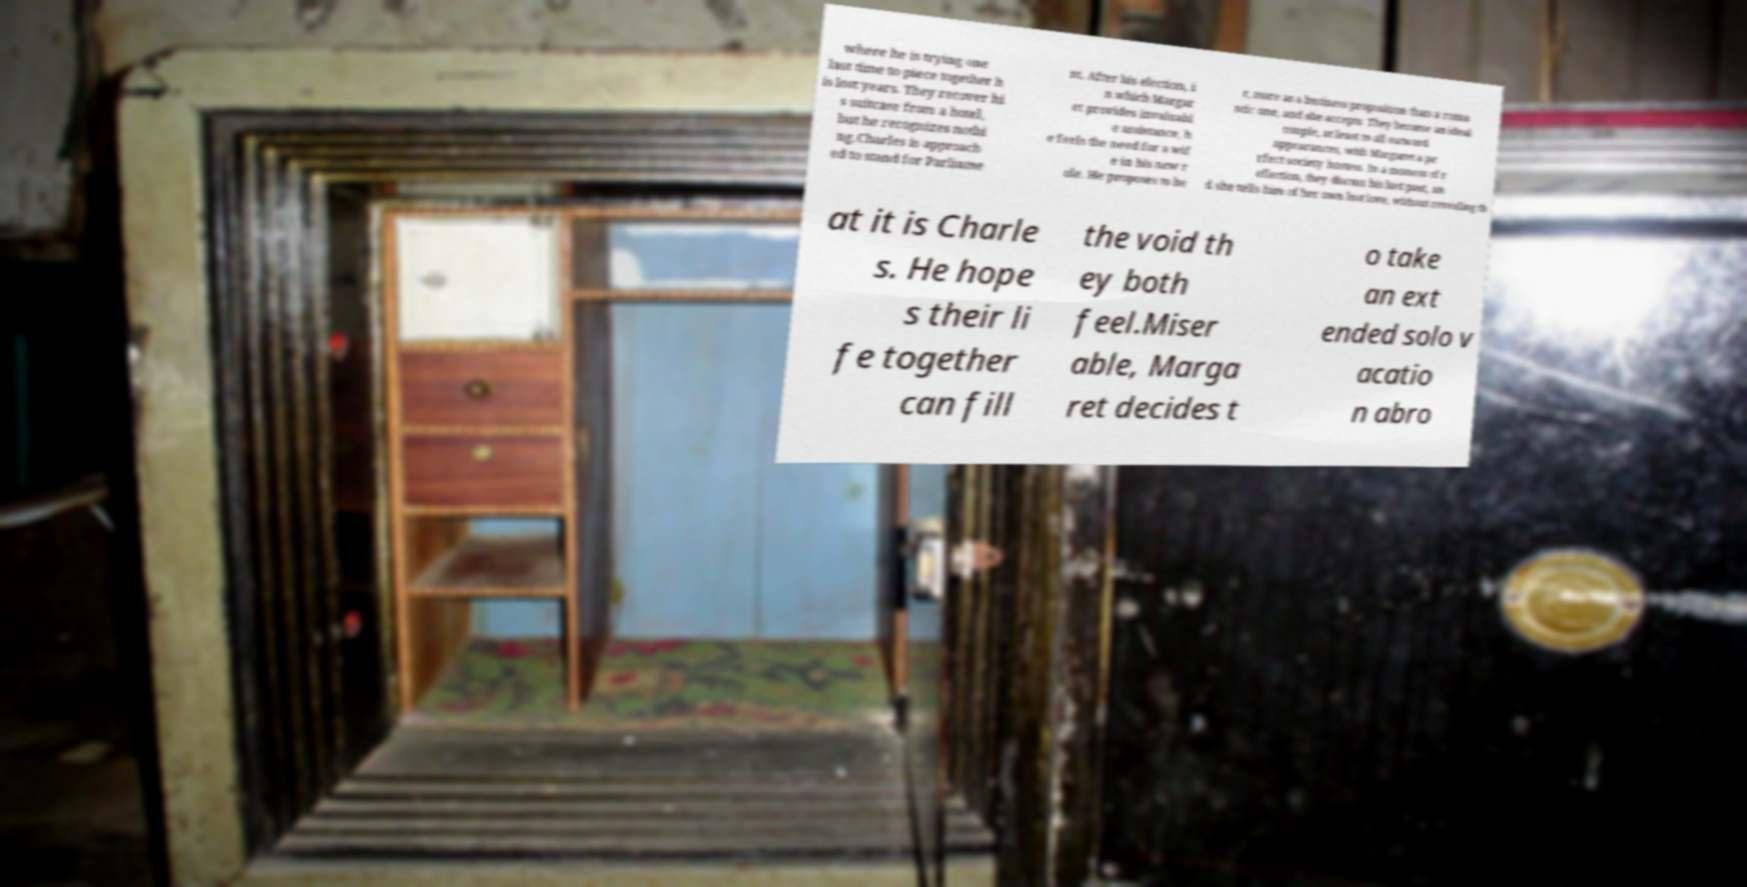Could you assist in decoding the text presented in this image and type it out clearly? where he is trying one last time to piece together h is lost years. They recover hi s suitcase from a hotel, but he recognizes nothi ng.Charles is approach ed to stand for Parliame nt. After his election, i n which Margar et provides invaluabl e assistance, h e feels the need for a wif e in his new r ole. He proposes to he r, more as a business proposition than a roma ntic one, and she accepts. They become an ideal couple, at least to all outward appearances, with Margaret a pe rfect society hostess. In a moment of r eflection, they discuss his lost past, an d she tells him of her own lost love, without revealing th at it is Charle s. He hope s their li fe together can fill the void th ey both feel.Miser able, Marga ret decides t o take an ext ended solo v acatio n abro 